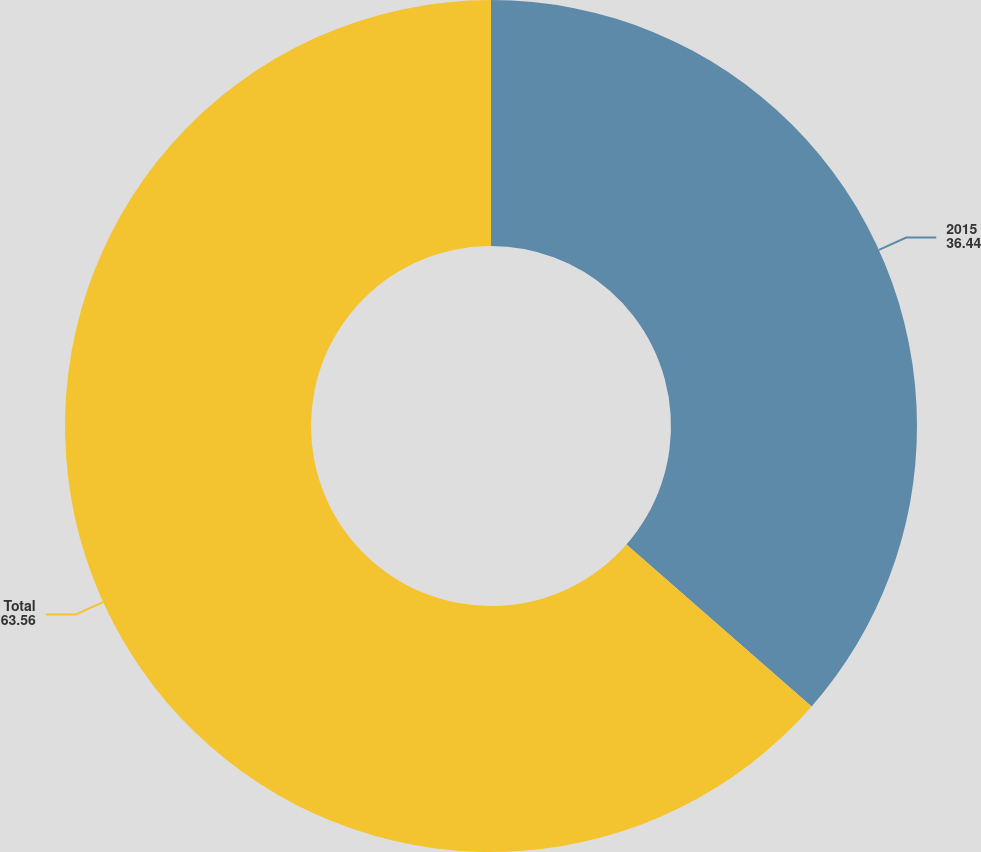Convert chart to OTSL. <chart><loc_0><loc_0><loc_500><loc_500><pie_chart><fcel>2015<fcel>Total<nl><fcel>36.44%<fcel>63.56%<nl></chart> 